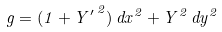<formula> <loc_0><loc_0><loc_500><loc_500>g = ( 1 + { Y ^ { \prime } } ^ { \, 2 } ) \, d x ^ { 2 } + Y ^ { 2 } \, d y ^ { 2 }</formula> 